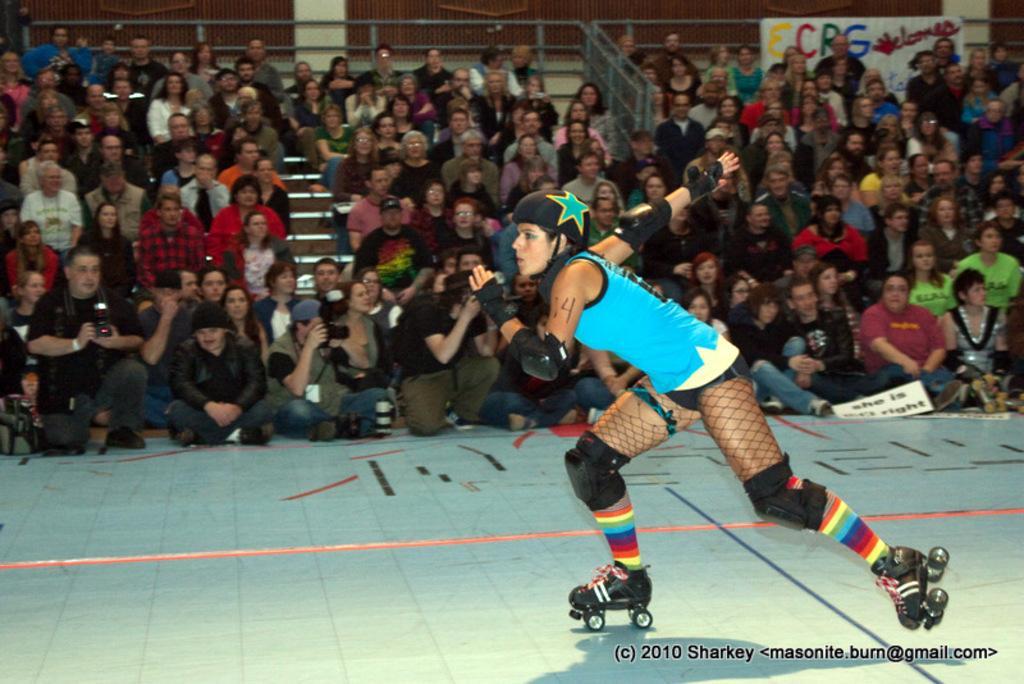In one or two sentences, can you explain what this image depicts? In this image I can see a person skating and the person is wearing blue and black color dress. Background I can see few other persons sitting and a white color board attached to the pole and I can see something written on the board. 